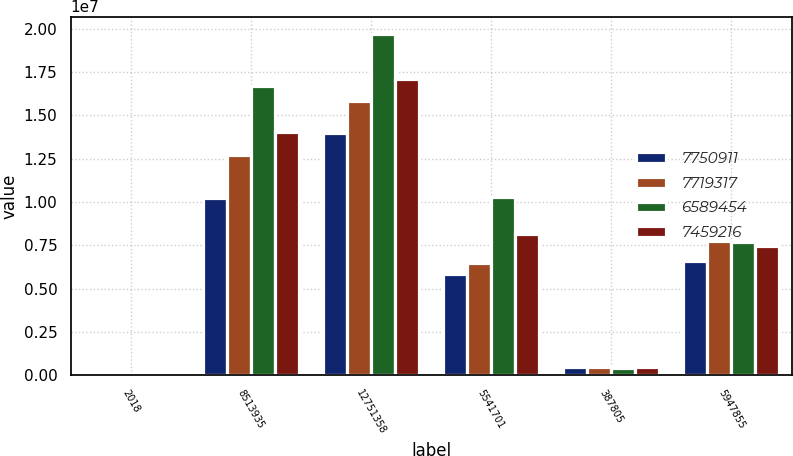<chart> <loc_0><loc_0><loc_500><loc_500><stacked_bar_chart><ecel><fcel>2018<fcel>8513935<fcel>12751358<fcel>5541701<fcel>387805<fcel>5947855<nl><fcel>7.75091e+06<fcel>2017<fcel>1.02061e+07<fcel>1.39829e+07<fcel>5.85513e+06<fcel>461954<fcel>6.58945e+06<nl><fcel>7.71932e+06<fcel>2016<fcel>1.27433e+07<fcel>1.58578e+07<fcel>6.48167e+06<fcel>473882<fcel>7.75091e+06<nl><fcel>6.58945e+06<fcel>2015<fcel>1.66816e+07<fcel>1.97276e+07<fcel>1.02755e+07<fcel>424206<fcel>7.71932e+06<nl><fcel>7.45922e+06<fcel>2014<fcel>1.40691e+07<fcel>1.70966e+07<fcel>8.17879e+06<fcel>496524<fcel>7.45922e+06<nl></chart> 